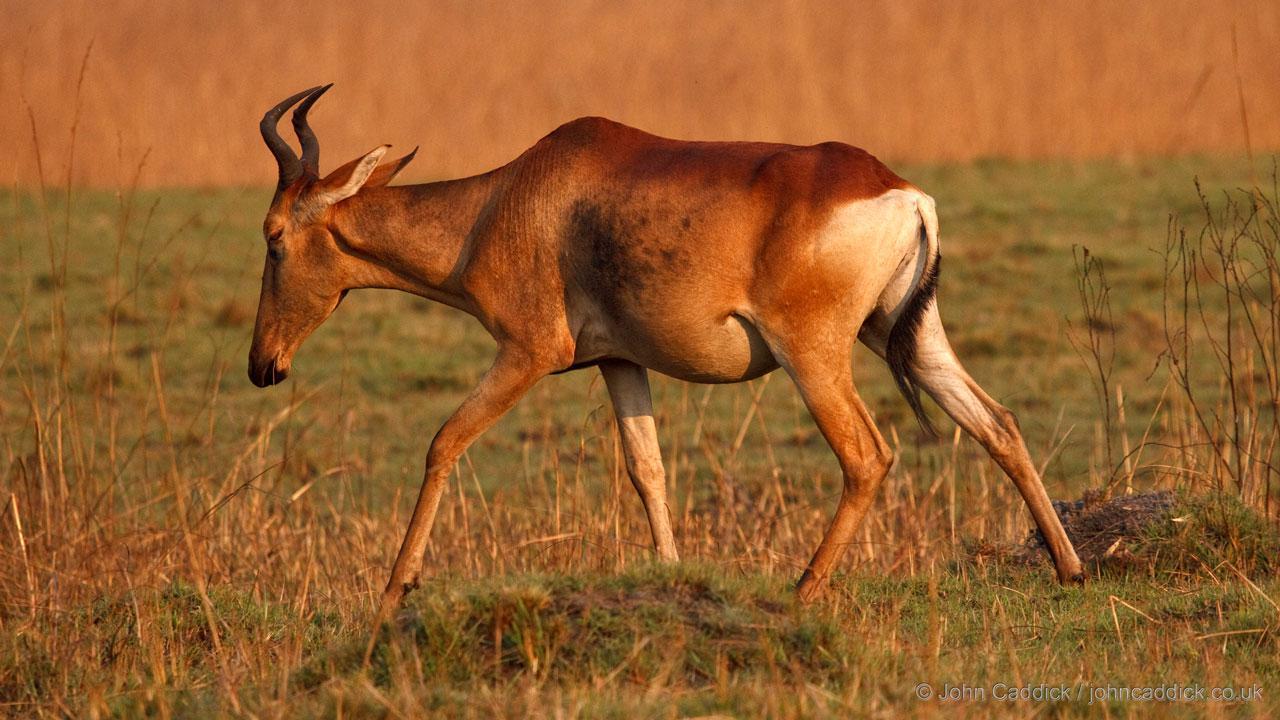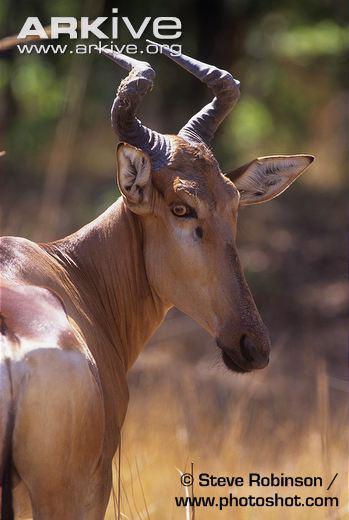The first image is the image on the left, the second image is the image on the right. Considering the images on both sides, is "Each image contains only one horned animal, and the animals on the left and right are gazing in the same direction." valid? Answer yes or no. No. The first image is the image on the left, the second image is the image on the right. For the images shown, is this caption "The animal in the left image is pointed to the right." true? Answer yes or no. No. 